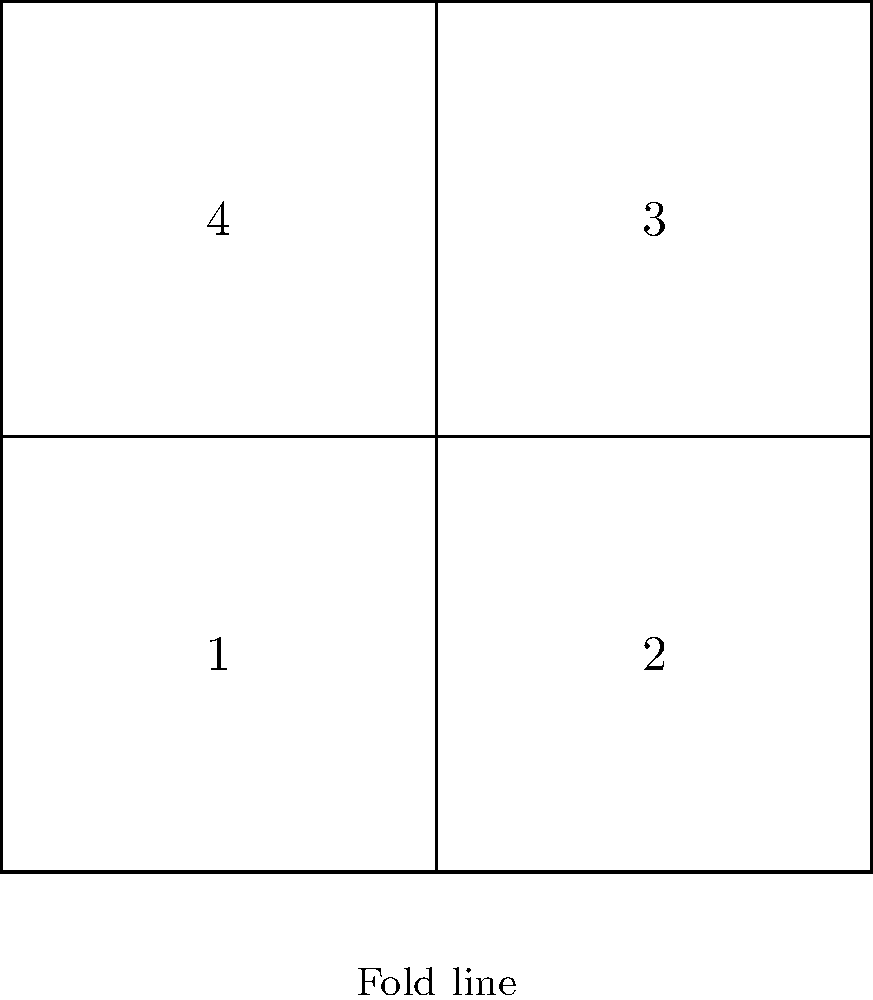As a fashion-forward entrepreneur, you're designing a unique origami-inspired top. The diagram shows a 2D pattern for the garment. When folded along the dashed lines, which numbered section will form the front of the 3D top? To determine which section will form the front of the 3D top, let's follow these steps:

1. Observe the fold lines: There are two dashed lines indicating where the pattern should be folded.

2. Visualize the folding process:
   - The vertical dashed line suggests folding the left half onto the right half.
   - The horizontal dashed line suggests folding the bottom half up to the top half.

3. Consider the resulting 3D shape:
   - After folding, the pattern will create a three-dimensional form with four layers.
   - The outermost layer will be the front of the top.

4. Identify the outermost section:
   - When folded, sections 2 and 3 will be on the inside.
   - Section 4 will be folded behind section 1.
   - Therefore, section 1 will be on the outside, forming the front of the 3D top.

5. Fashion design perspective:
   - This origami-inspired design creates an interesting asymmetrical look.
   - Section 1 being the front allows for unique design elements or patterns to be showcased prominently.
Answer: 1 